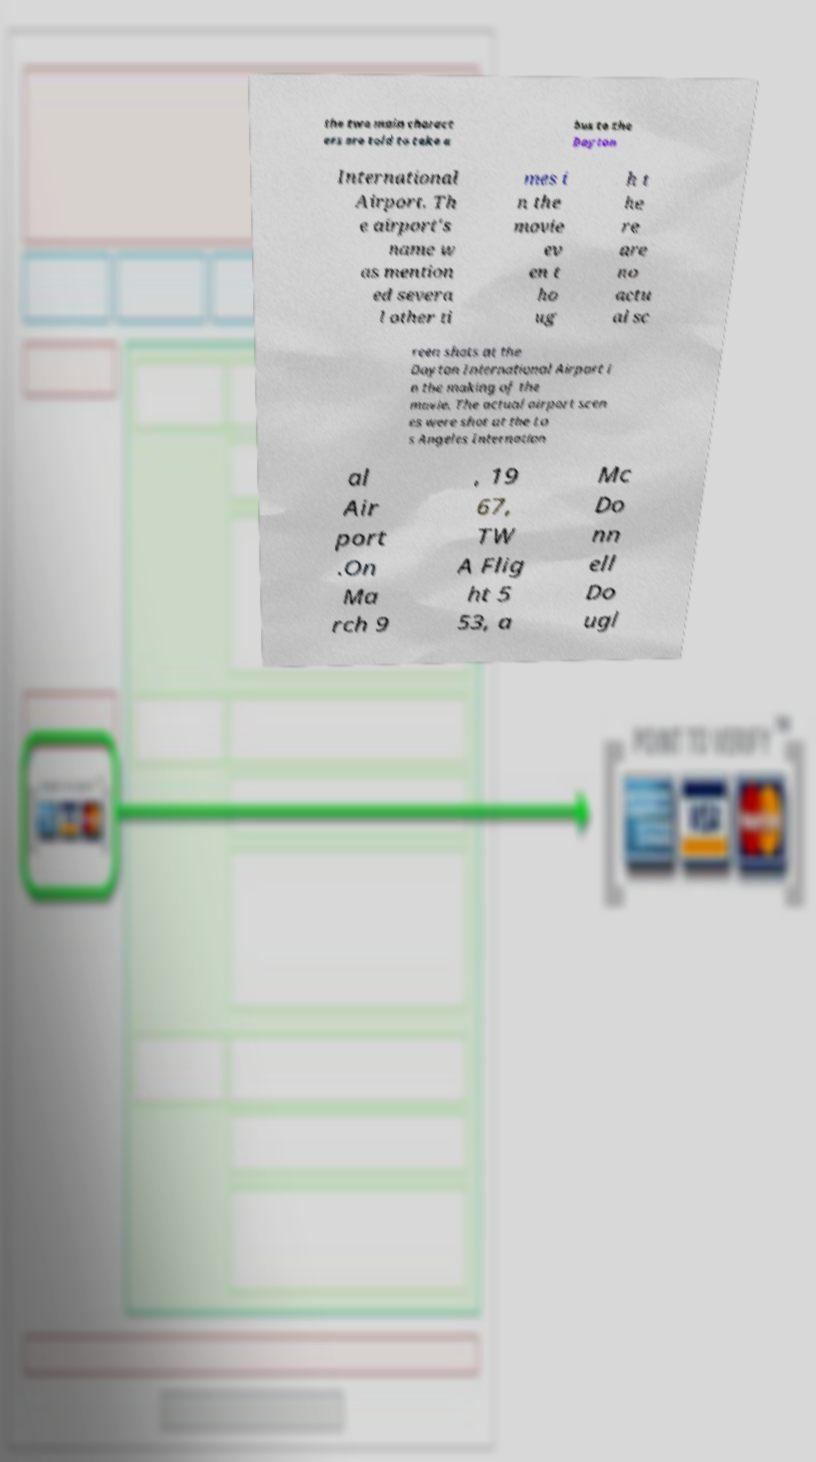Please identify and transcribe the text found in this image. the two main charact ers are told to take a bus to the Dayton International Airport. Th e airport's name w as mention ed severa l other ti mes i n the movie ev en t ho ug h t he re are no actu al sc reen shots at the Dayton International Airport i n the making of the movie. The actual airport scen es were shot at the Lo s Angeles Internation al Air port .On Ma rch 9 , 19 67, TW A Flig ht 5 53, a Mc Do nn ell Do ugl 